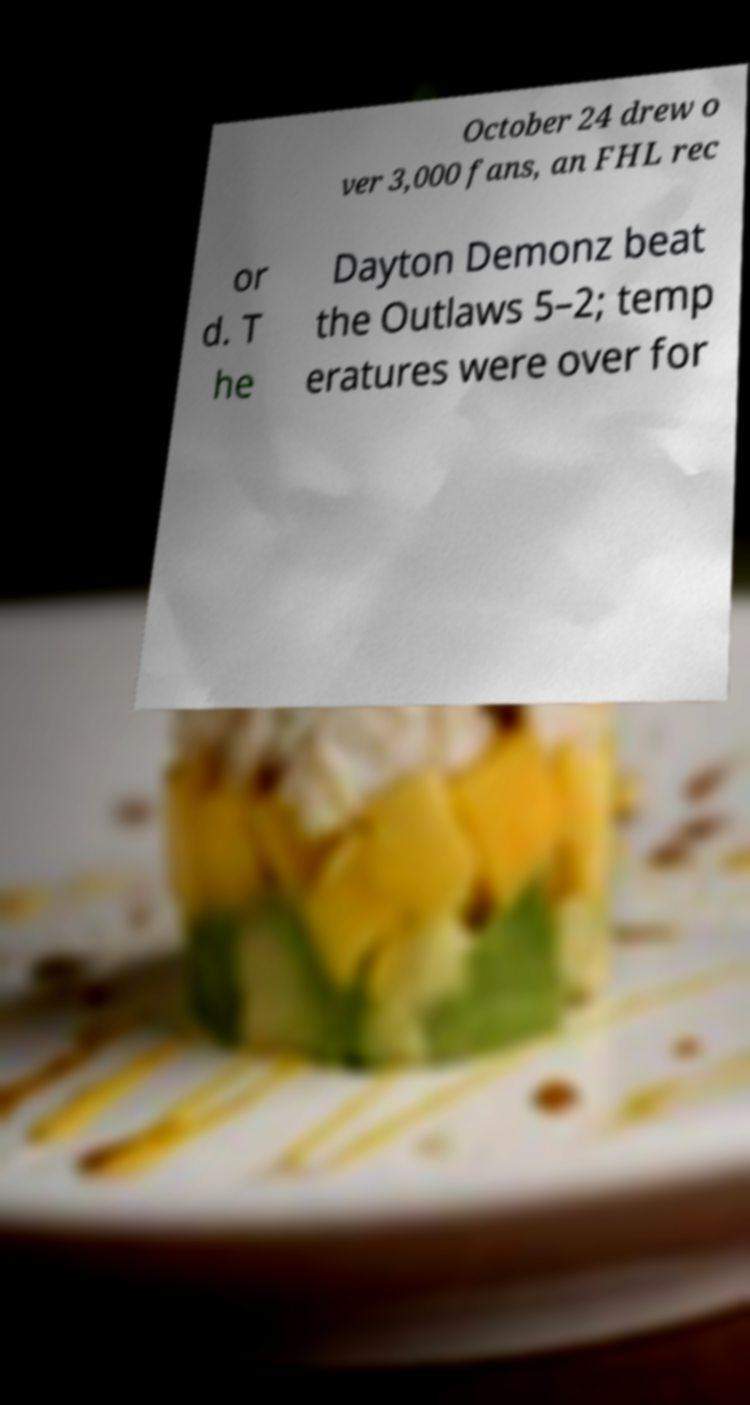For documentation purposes, I need the text within this image transcribed. Could you provide that? October 24 drew o ver 3,000 fans, an FHL rec or d. T he Dayton Demonz beat the Outlaws 5–2; temp eratures were over for 